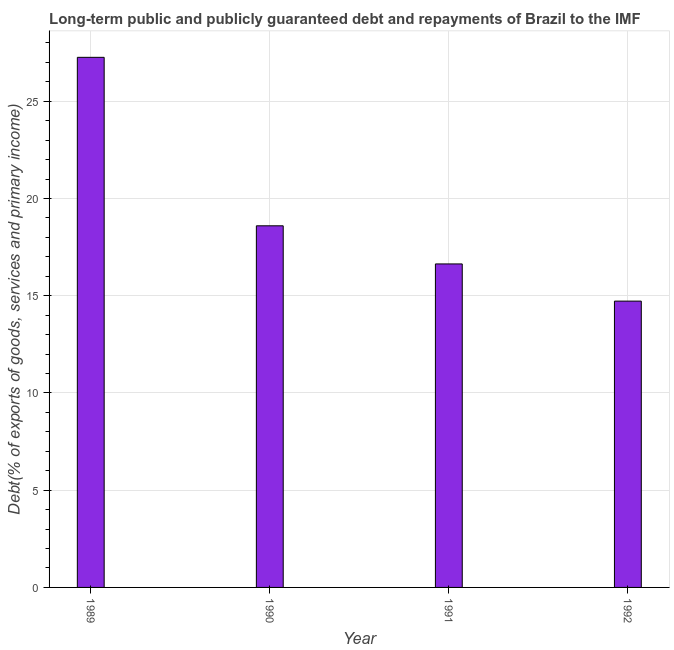Does the graph contain any zero values?
Provide a succinct answer. No. Does the graph contain grids?
Make the answer very short. Yes. What is the title of the graph?
Your response must be concise. Long-term public and publicly guaranteed debt and repayments of Brazil to the IMF. What is the label or title of the Y-axis?
Give a very brief answer. Debt(% of exports of goods, services and primary income). What is the debt service in 1991?
Your response must be concise. 16.64. Across all years, what is the maximum debt service?
Offer a terse response. 27.26. Across all years, what is the minimum debt service?
Your answer should be compact. 14.72. In which year was the debt service maximum?
Keep it short and to the point. 1989. What is the sum of the debt service?
Make the answer very short. 77.22. What is the difference between the debt service in 1990 and 1992?
Give a very brief answer. 3.87. What is the average debt service per year?
Keep it short and to the point. 19.3. What is the median debt service?
Give a very brief answer. 17.62. In how many years, is the debt service greater than 15 %?
Your answer should be compact. 3. What is the ratio of the debt service in 1991 to that in 1992?
Ensure brevity in your answer.  1.13. What is the difference between the highest and the second highest debt service?
Your answer should be very brief. 8.66. Is the sum of the debt service in 1989 and 1992 greater than the maximum debt service across all years?
Give a very brief answer. Yes. What is the difference between the highest and the lowest debt service?
Keep it short and to the point. 12.54. In how many years, is the debt service greater than the average debt service taken over all years?
Keep it short and to the point. 1. How many bars are there?
Your response must be concise. 4. Are the values on the major ticks of Y-axis written in scientific E-notation?
Make the answer very short. No. What is the Debt(% of exports of goods, services and primary income) in 1989?
Your answer should be very brief. 27.26. What is the Debt(% of exports of goods, services and primary income) in 1990?
Your answer should be compact. 18.6. What is the Debt(% of exports of goods, services and primary income) in 1991?
Offer a very short reply. 16.64. What is the Debt(% of exports of goods, services and primary income) of 1992?
Offer a terse response. 14.72. What is the difference between the Debt(% of exports of goods, services and primary income) in 1989 and 1990?
Your response must be concise. 8.66. What is the difference between the Debt(% of exports of goods, services and primary income) in 1989 and 1991?
Provide a short and direct response. 10.62. What is the difference between the Debt(% of exports of goods, services and primary income) in 1989 and 1992?
Offer a very short reply. 12.54. What is the difference between the Debt(% of exports of goods, services and primary income) in 1990 and 1991?
Your response must be concise. 1.96. What is the difference between the Debt(% of exports of goods, services and primary income) in 1990 and 1992?
Ensure brevity in your answer.  3.87. What is the difference between the Debt(% of exports of goods, services and primary income) in 1991 and 1992?
Your answer should be very brief. 1.91. What is the ratio of the Debt(% of exports of goods, services and primary income) in 1989 to that in 1990?
Provide a short and direct response. 1.47. What is the ratio of the Debt(% of exports of goods, services and primary income) in 1989 to that in 1991?
Keep it short and to the point. 1.64. What is the ratio of the Debt(% of exports of goods, services and primary income) in 1989 to that in 1992?
Offer a terse response. 1.85. What is the ratio of the Debt(% of exports of goods, services and primary income) in 1990 to that in 1991?
Offer a terse response. 1.12. What is the ratio of the Debt(% of exports of goods, services and primary income) in 1990 to that in 1992?
Provide a succinct answer. 1.26. What is the ratio of the Debt(% of exports of goods, services and primary income) in 1991 to that in 1992?
Offer a terse response. 1.13. 